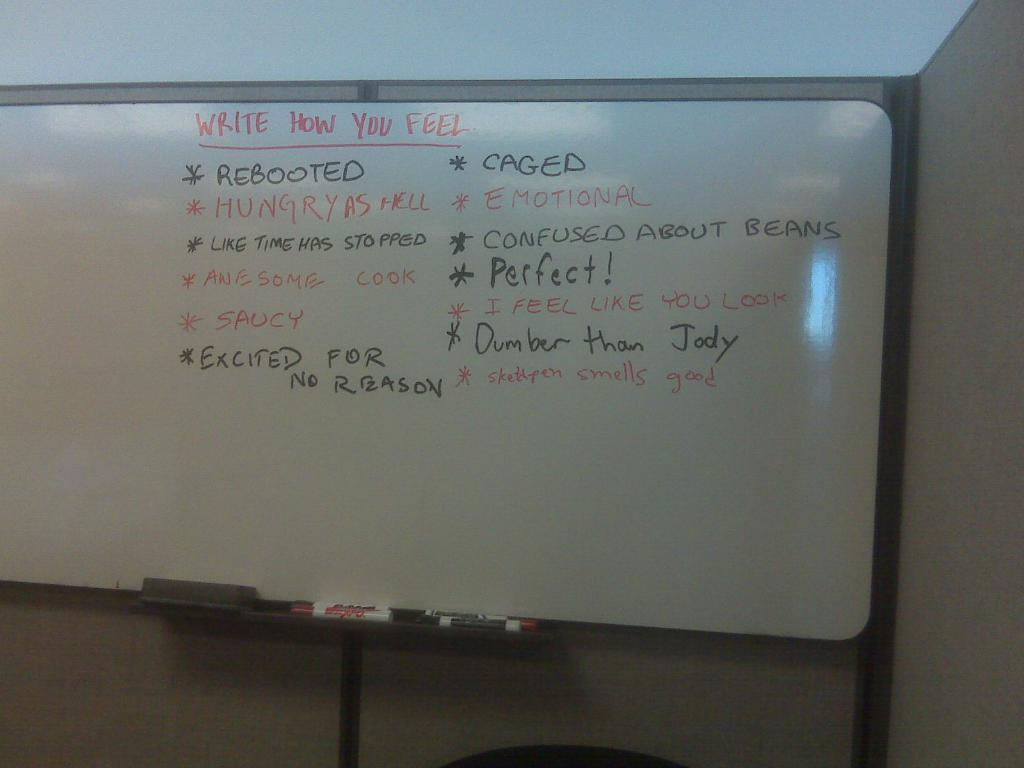Provide a one-sentence caption for the provided image. A white board with the direction; Write How You Feel, followed by some examples. 